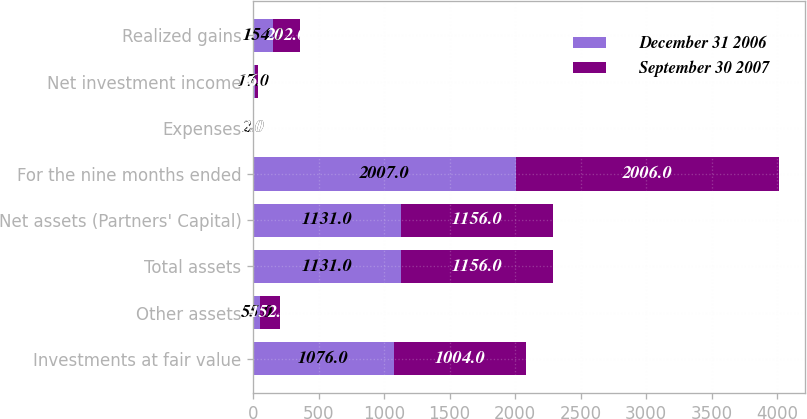<chart> <loc_0><loc_0><loc_500><loc_500><stacked_bar_chart><ecel><fcel>Investments at fair value<fcel>Other assets<fcel>Total assets<fcel>Net assets (Partners' Capital)<fcel>For the nine months ended<fcel>Expenses<fcel>Net investment income<fcel>Realized gains<nl><fcel>December 31 2006<fcel>1076<fcel>55<fcel>1131<fcel>1131<fcel>2007<fcel>2<fcel>17<fcel>154<nl><fcel>September 30 2007<fcel>1004<fcel>152<fcel>1156<fcel>1156<fcel>2006<fcel>3<fcel>16<fcel>202<nl></chart> 